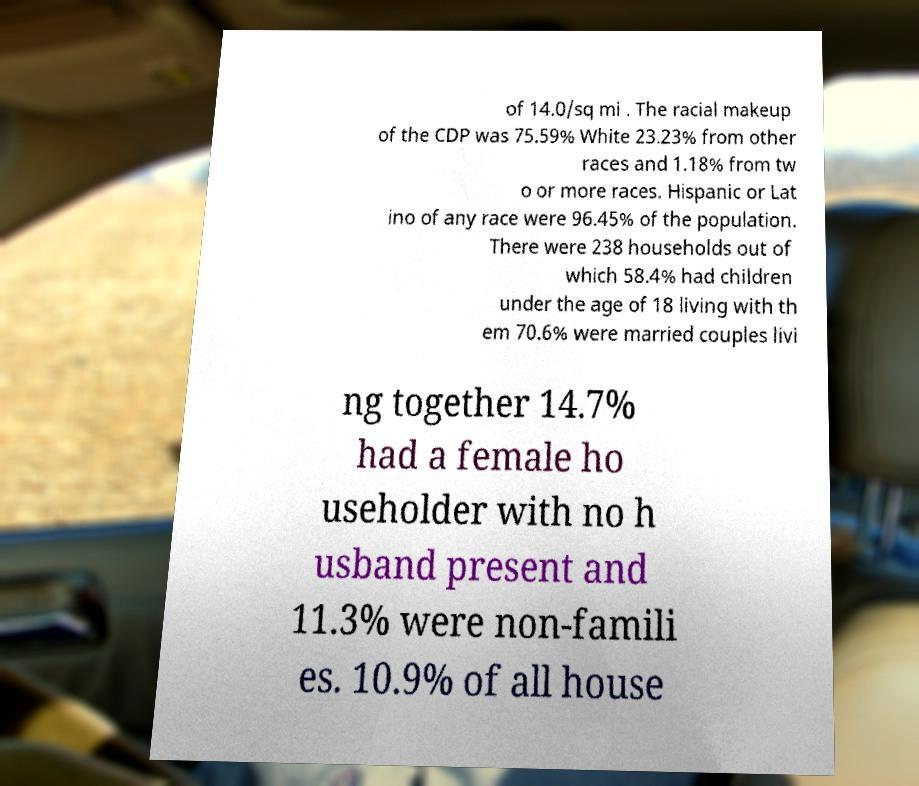Can you accurately transcribe the text from the provided image for me? of 14.0/sq mi . The racial makeup of the CDP was 75.59% White 23.23% from other races and 1.18% from tw o or more races. Hispanic or Lat ino of any race were 96.45% of the population. There were 238 households out of which 58.4% had children under the age of 18 living with th em 70.6% were married couples livi ng together 14.7% had a female ho useholder with no h usband present and 11.3% were non-famili es. 10.9% of all house 